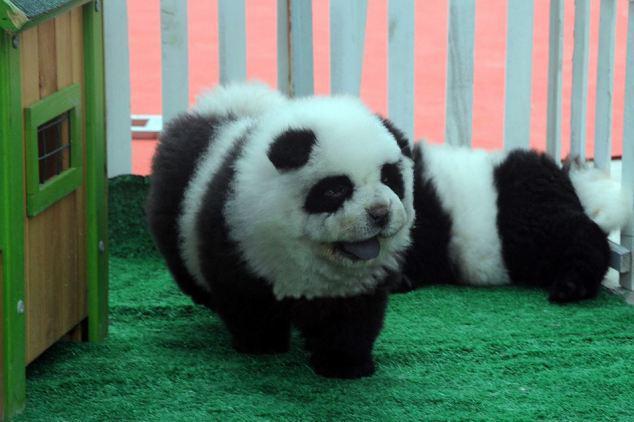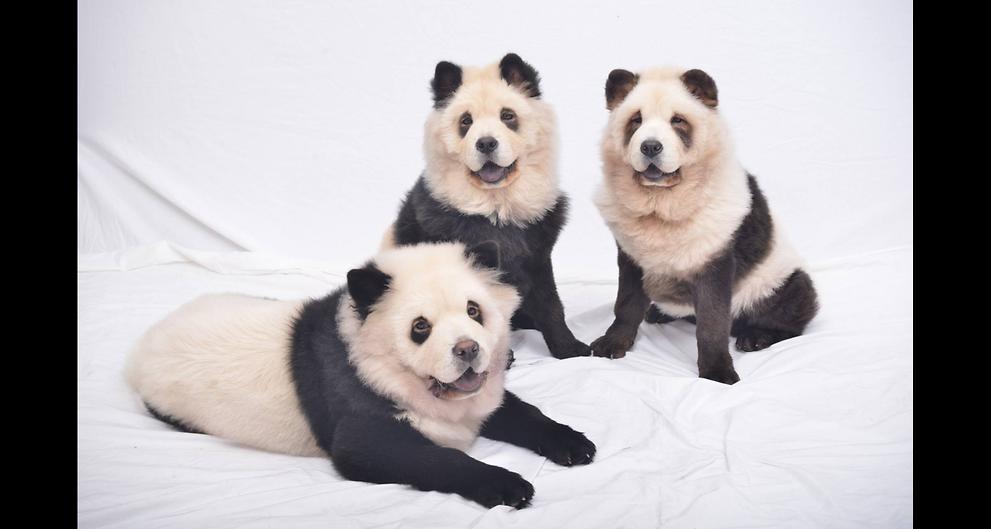The first image is the image on the left, the second image is the image on the right. For the images shown, is this caption "An image shows three panda-look chows, with one reclining and two sitting up." true? Answer yes or no. Yes. The first image is the image on the left, the second image is the image on the right. Assess this claim about the two images: "There's at least three dogs in the right image.". Correct or not? Answer yes or no. Yes. 